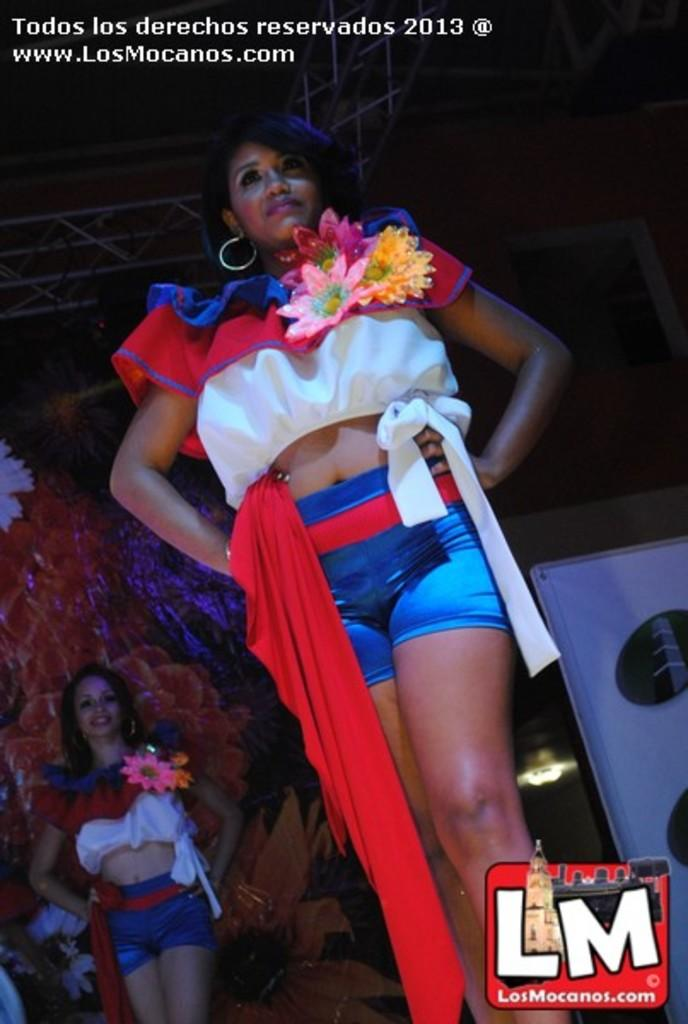<image>
Present a compact description of the photo's key features. A 2013 photo from LosMocanos.com shows women in red white and blue wearing flowers dancing. 